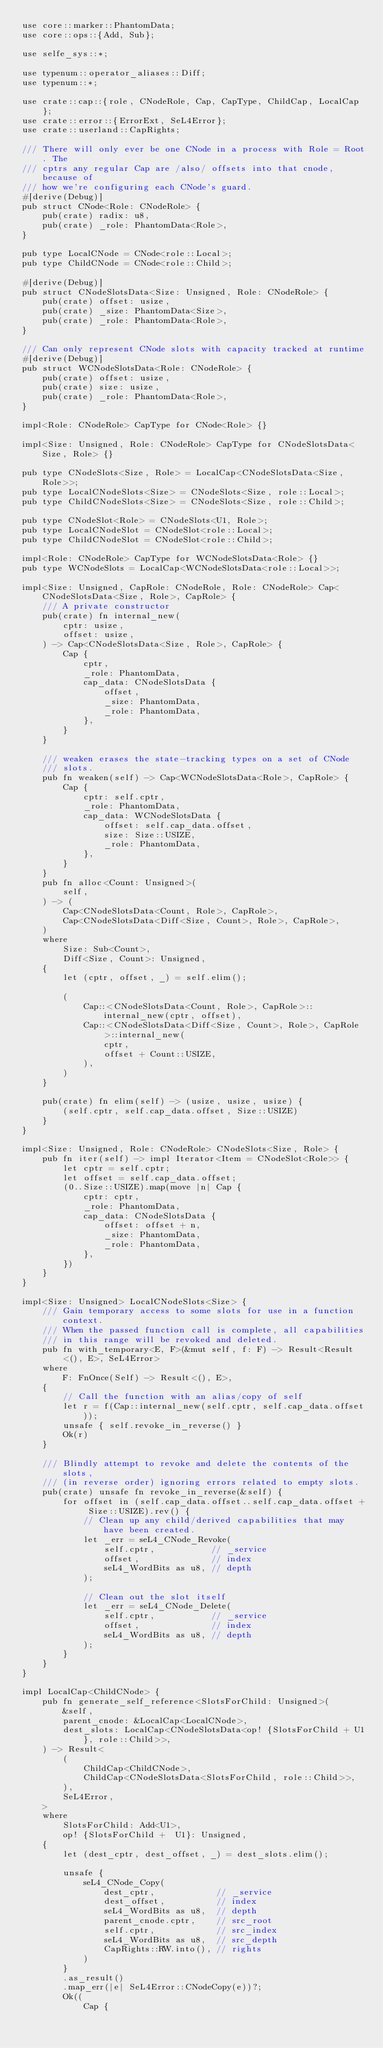Convert code to text. <code><loc_0><loc_0><loc_500><loc_500><_Rust_>use core::marker::PhantomData;
use core::ops::{Add, Sub};

use selfe_sys::*;

use typenum::operator_aliases::Diff;
use typenum::*;

use crate::cap::{role, CNodeRole, Cap, CapType, ChildCap, LocalCap};
use crate::error::{ErrorExt, SeL4Error};
use crate::userland::CapRights;

/// There will only ever be one CNode in a process with Role = Root. The
/// cptrs any regular Cap are /also/ offsets into that cnode, because of
/// how we're configuring each CNode's guard.
#[derive(Debug)]
pub struct CNode<Role: CNodeRole> {
    pub(crate) radix: u8,
    pub(crate) _role: PhantomData<Role>,
}

pub type LocalCNode = CNode<role::Local>;
pub type ChildCNode = CNode<role::Child>;

#[derive(Debug)]
pub struct CNodeSlotsData<Size: Unsigned, Role: CNodeRole> {
    pub(crate) offset: usize,
    pub(crate) _size: PhantomData<Size>,
    pub(crate) _role: PhantomData<Role>,
}

/// Can only represent CNode slots with capacity tracked at runtime
#[derive(Debug)]
pub struct WCNodeSlotsData<Role: CNodeRole> {
    pub(crate) offset: usize,
    pub(crate) size: usize,
    pub(crate) _role: PhantomData<Role>,
}

impl<Role: CNodeRole> CapType for CNode<Role> {}

impl<Size: Unsigned, Role: CNodeRole> CapType for CNodeSlotsData<Size, Role> {}

pub type CNodeSlots<Size, Role> = LocalCap<CNodeSlotsData<Size, Role>>;
pub type LocalCNodeSlots<Size> = CNodeSlots<Size, role::Local>;
pub type ChildCNodeSlots<Size> = CNodeSlots<Size, role::Child>;

pub type CNodeSlot<Role> = CNodeSlots<U1, Role>;
pub type LocalCNodeSlot = CNodeSlot<role::Local>;
pub type ChildCNodeSlot = CNodeSlot<role::Child>;

impl<Role: CNodeRole> CapType for WCNodeSlotsData<Role> {}
pub type WCNodeSlots = LocalCap<WCNodeSlotsData<role::Local>>;

impl<Size: Unsigned, CapRole: CNodeRole, Role: CNodeRole> Cap<CNodeSlotsData<Size, Role>, CapRole> {
    /// A private constructor
    pub(crate) fn internal_new(
        cptr: usize,
        offset: usize,
    ) -> Cap<CNodeSlotsData<Size, Role>, CapRole> {
        Cap {
            cptr,
            _role: PhantomData,
            cap_data: CNodeSlotsData {
                offset,
                _size: PhantomData,
                _role: PhantomData,
            },
        }
    }

    /// weaken erases the state-tracking types on a set of CNode
    /// slots.
    pub fn weaken(self) -> Cap<WCNodeSlotsData<Role>, CapRole> {
        Cap {
            cptr: self.cptr,
            _role: PhantomData,
            cap_data: WCNodeSlotsData {
                offset: self.cap_data.offset,
                size: Size::USIZE,
                _role: PhantomData,
            },
        }
    }
    pub fn alloc<Count: Unsigned>(
        self,
    ) -> (
        Cap<CNodeSlotsData<Count, Role>, CapRole>,
        Cap<CNodeSlotsData<Diff<Size, Count>, Role>, CapRole>,
    )
    where
        Size: Sub<Count>,
        Diff<Size, Count>: Unsigned,
    {
        let (cptr, offset, _) = self.elim();

        (
            Cap::<CNodeSlotsData<Count, Role>, CapRole>::internal_new(cptr, offset),
            Cap::<CNodeSlotsData<Diff<Size, Count>, Role>, CapRole>::internal_new(
                cptr,
                offset + Count::USIZE,
            ),
        )
    }

    pub(crate) fn elim(self) -> (usize, usize, usize) {
        (self.cptr, self.cap_data.offset, Size::USIZE)
    }
}

impl<Size: Unsigned, Role: CNodeRole> CNodeSlots<Size, Role> {
    pub fn iter(self) -> impl Iterator<Item = CNodeSlot<Role>> {
        let cptr = self.cptr;
        let offset = self.cap_data.offset;
        (0..Size::USIZE).map(move |n| Cap {
            cptr: cptr,
            _role: PhantomData,
            cap_data: CNodeSlotsData {
                offset: offset + n,
                _size: PhantomData,
                _role: PhantomData,
            },
        })
    }
}

impl<Size: Unsigned> LocalCNodeSlots<Size> {
    /// Gain temporary access to some slots for use in a function context.
    /// When the passed function call is complete, all capabilities
    /// in this range will be revoked and deleted.
    pub fn with_temporary<E, F>(&mut self, f: F) -> Result<Result<(), E>, SeL4Error>
    where
        F: FnOnce(Self) -> Result<(), E>,
    {
        // Call the function with an alias/copy of self
        let r = f(Cap::internal_new(self.cptr, self.cap_data.offset));
        unsafe { self.revoke_in_reverse() }
        Ok(r)
    }

    /// Blindly attempt to revoke and delete the contents of the slots,
    /// (in reverse order) ignoring errors related to empty slots.
    pub(crate) unsafe fn revoke_in_reverse(&self) {
        for offset in (self.cap_data.offset..self.cap_data.offset + Size::USIZE).rev() {
            // Clean up any child/derived capabilities that may have been created.
            let _err = seL4_CNode_Revoke(
                self.cptr,           // _service
                offset,              // index
                seL4_WordBits as u8, // depth
            );

            // Clean out the slot itself
            let _err = seL4_CNode_Delete(
                self.cptr,           // _service
                offset,              // index
                seL4_WordBits as u8, // depth
            );
        }
    }
}

impl LocalCap<ChildCNode> {
    pub fn generate_self_reference<SlotsForChild: Unsigned>(
        &self,
        parent_cnode: &LocalCap<LocalCNode>,
        dest_slots: LocalCap<CNodeSlotsData<op! {SlotsForChild + U1}, role::Child>>,
    ) -> Result<
        (
            ChildCap<ChildCNode>,
            ChildCap<CNodeSlotsData<SlotsForChild, role::Child>>,
        ),
        SeL4Error,
    >
    where
        SlotsForChild: Add<U1>,
        op! {SlotsForChild +  U1}: Unsigned,
    {
        let (dest_cptr, dest_offset, _) = dest_slots.elim();

        unsafe {
            seL4_CNode_Copy(
                dest_cptr,            // _service
                dest_offset,          // index
                seL4_WordBits as u8,  // depth
                parent_cnode.cptr,    // src_root
                self.cptr,            // src_index
                seL4_WordBits as u8,  // src_depth
                CapRights::RW.into(), // rights
            )
        }
        .as_result()
        .map_err(|e| SeL4Error::CNodeCopy(e))?;
        Ok((
            Cap {</code> 